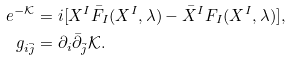Convert formula to latex. <formula><loc_0><loc_0><loc_500><loc_500>e ^ { - \mathcal { K } } & = i [ X ^ { I } \bar { F } _ { I } ( X ^ { I } , \lambda ) - \bar { X } ^ { I } F _ { I } ( X ^ { I } , \lambda ) ] , \\ g _ { i \bar { j } } & = \partial _ { i } \bar { \partial } _ { \bar { j } } \mathcal { K } .</formula> 